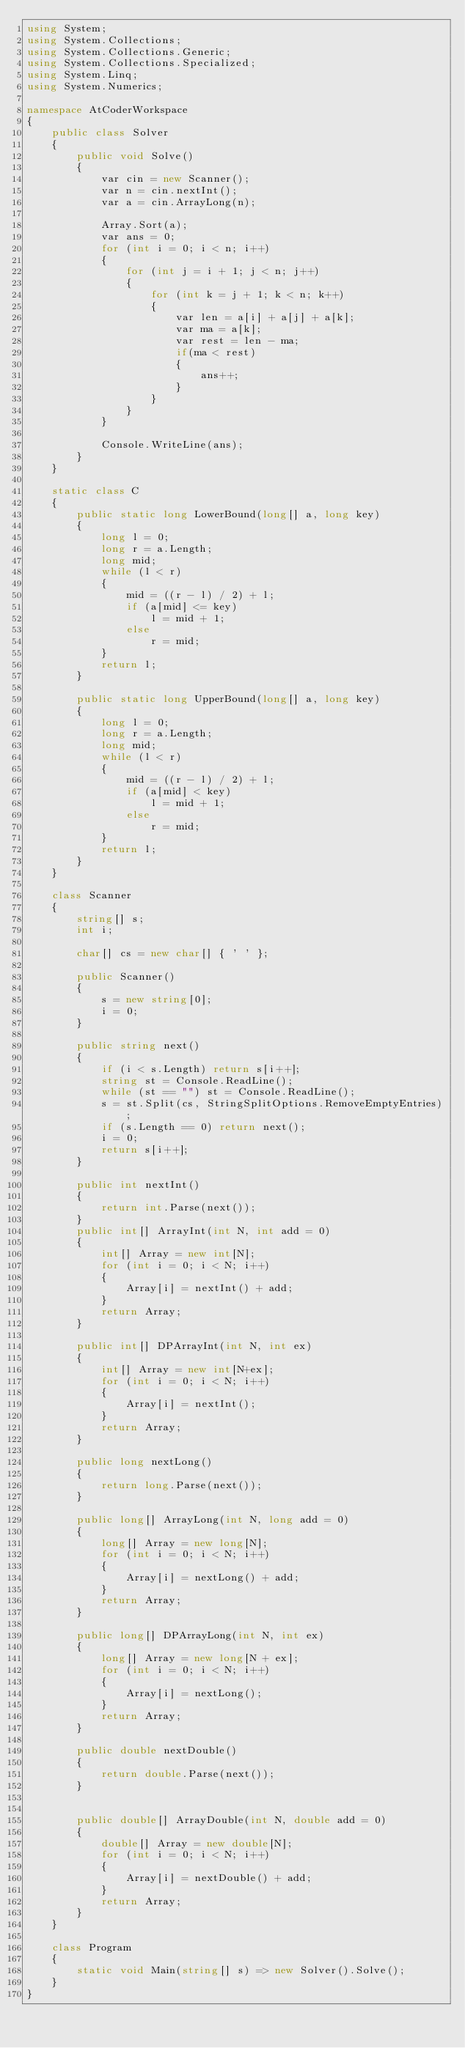Convert code to text. <code><loc_0><loc_0><loc_500><loc_500><_C#_>using System;
using System.Collections;
using System.Collections.Generic;
using System.Collections.Specialized;
using System.Linq;
using System.Numerics;

namespace AtCoderWorkspace
{
    public class Solver
    {
        public void Solve()
        {
            var cin = new Scanner();
            var n = cin.nextInt();
            var a = cin.ArrayLong(n);

            Array.Sort(a);
            var ans = 0;
            for (int i = 0; i < n; i++)
            {
                for (int j = i + 1; j < n; j++)
                {
                    for (int k = j + 1; k < n; k++)
                    {
                        var len = a[i] + a[j] + a[k];
                        var ma = a[k];
                        var rest = len - ma;
                        if(ma < rest)
                        {
                            ans++;
                        }
                    }
                }
            }

            Console.WriteLine(ans);
        }
    }

    static class C
    {
        public static long LowerBound(long[] a, long key)
        {
            long l = 0;
            long r = a.Length;
            long mid;
            while (l < r)
            {
                mid = ((r - l) / 2) + l;
                if (a[mid] <= key)
                    l = mid + 1;
                else
                    r = mid;
            }
            return l;
        }

        public static long UpperBound(long[] a, long key)
        {
            long l = 0;
            long r = a.Length;
            long mid;
            while (l < r)
            {
                mid = ((r - l) / 2) + l;
                if (a[mid] < key)
                    l = mid + 1;
                else
                    r = mid;
            }
            return l;
        }
    }

    class Scanner
    {
        string[] s;
        int i;

        char[] cs = new char[] { ' ' };

        public Scanner()
        {
            s = new string[0];
            i = 0;
        }

        public string next()
        {
            if (i < s.Length) return s[i++];
            string st = Console.ReadLine();
            while (st == "") st = Console.ReadLine();
            s = st.Split(cs, StringSplitOptions.RemoveEmptyEntries);
            if (s.Length == 0) return next();
            i = 0;
            return s[i++];
        }

        public int nextInt()
        {
            return int.Parse(next());
        }
        public int[] ArrayInt(int N, int add = 0)
        {
            int[] Array = new int[N];
            for (int i = 0; i < N; i++)
            {
                Array[i] = nextInt() + add;
            }
            return Array;
        }

        public int[] DPArrayInt(int N, int ex)
        {
            int[] Array = new int[N+ex];
            for (int i = 0; i < N; i++)
            {
                Array[i] = nextInt();
            }
            return Array;
        }

        public long nextLong()
        {
            return long.Parse(next());
        }

        public long[] ArrayLong(int N, long add = 0)
        {
            long[] Array = new long[N];
            for (int i = 0; i < N; i++)
            {
                Array[i] = nextLong() + add;
            }
            return Array;
        }

        public long[] DPArrayLong(int N, int ex)
        {
            long[] Array = new long[N + ex];
            for (int i = 0; i < N; i++)
            {
                Array[i] = nextLong();
            }
            return Array;
        }

        public double nextDouble()
        {
            return double.Parse(next());
        }


        public double[] ArrayDouble(int N, double add = 0)
        {
            double[] Array = new double[N];
            for (int i = 0; i < N; i++)
            {
                Array[i] = nextDouble() + add;
            }
            return Array;
        }
    }   

    class Program
    {
        static void Main(string[] s) => new Solver().Solve();
    }
}
</code> 